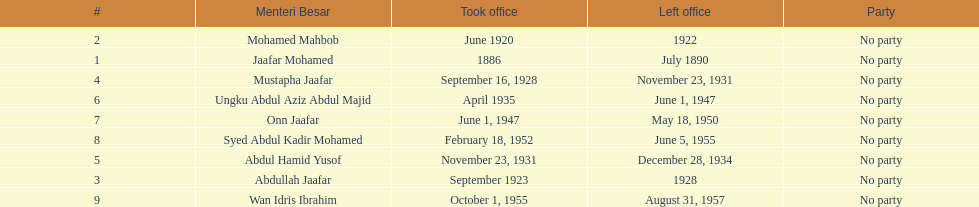Who took office after abdullah jaafar? Mustapha Jaafar. 